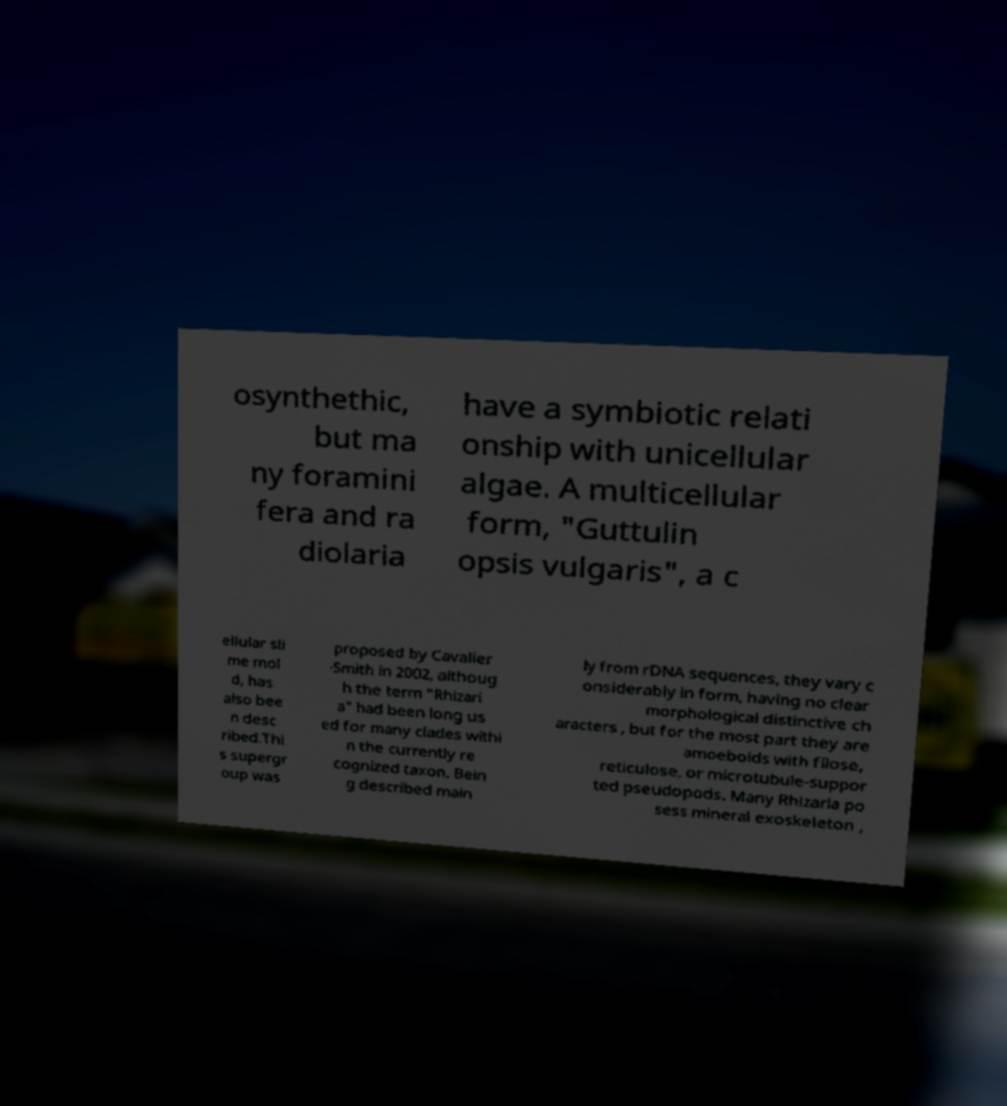Please read and relay the text visible in this image. What does it say? osynthethic, but ma ny foramini fera and ra diolaria have a symbiotic relati onship with unicellular algae. A multicellular form, "Guttulin opsis vulgaris", a c ellular sli me mol d, has also bee n desc ribed.Thi s supergr oup was proposed by Cavalier -Smith in 2002, althoug h the term "Rhizari a" had been long us ed for many clades withi n the currently re cognized taxon. Bein g described main ly from rDNA sequences, they vary c onsiderably in form, having no clear morphological distinctive ch aracters , but for the most part they are amoeboids with filose, reticulose, or microtubule-suppor ted pseudopods. Many Rhizaria po sess mineral exoskeleton , 